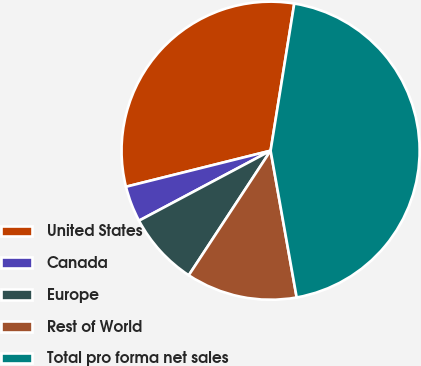Convert chart. <chart><loc_0><loc_0><loc_500><loc_500><pie_chart><fcel>United States<fcel>Canada<fcel>Europe<fcel>Rest of World<fcel>Total pro forma net sales<nl><fcel>31.43%<fcel>3.89%<fcel>7.97%<fcel>12.05%<fcel>44.66%<nl></chart> 